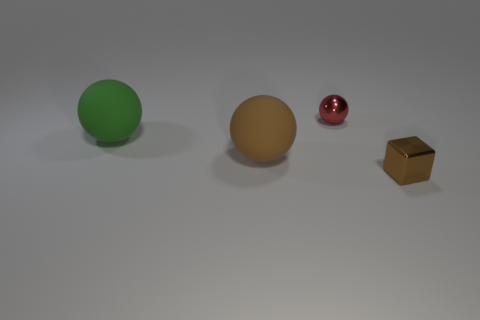There is a metallic object behind the green thing; what is its shape?
Provide a succinct answer. Sphere. What color is the tiny metallic ball?
Make the answer very short. Red. There is another object that is the same material as the small red thing; what is its shape?
Make the answer very short. Cube. Do the brown thing in front of the brown ball and the green rubber thing have the same size?
Ensure brevity in your answer.  No. What number of objects are brown spheres that are behind the shiny block or tiny objects that are left of the tiny metal block?
Keep it short and to the point. 2. Is the color of the sphere in front of the green object the same as the metal sphere?
Provide a short and direct response. No. What number of rubber things are large brown balls or big purple cylinders?
Ensure brevity in your answer.  1. The tiny red shiny object is what shape?
Your response must be concise. Sphere. Is there anything else that has the same material as the green ball?
Your answer should be very brief. Yes. Is the material of the small red ball the same as the big brown sphere?
Give a very brief answer. No. 